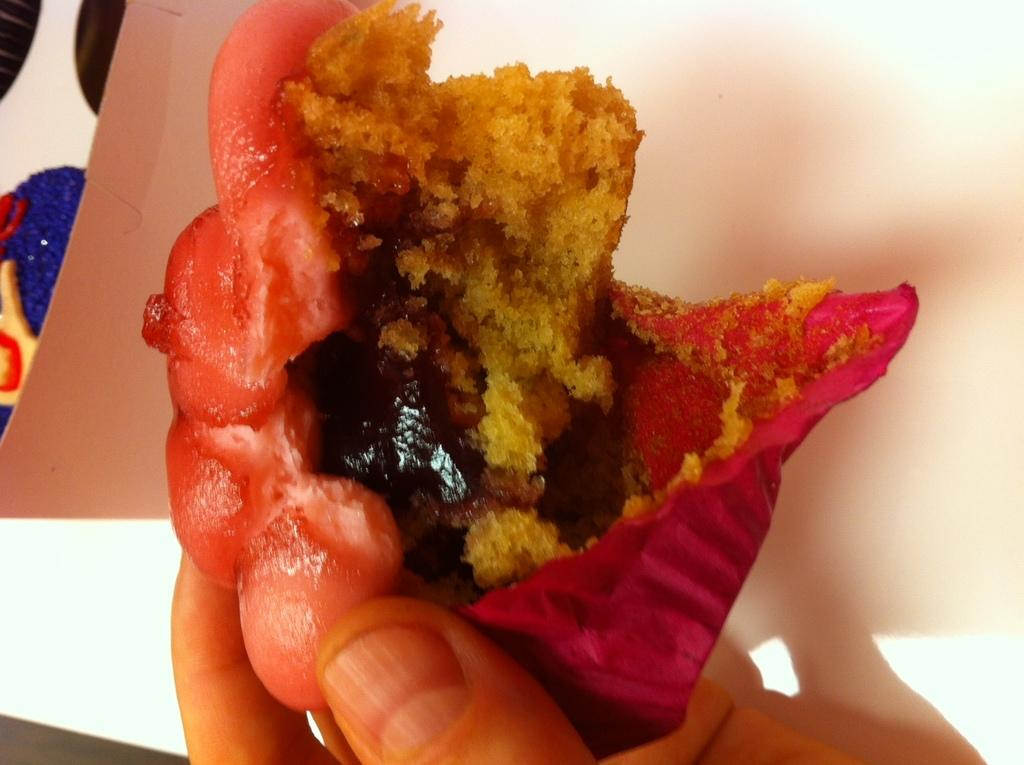What is being held by the person's hand in the foreground of the image? There is a person's hand holding a cupcake piece in the foreground of the image. What can be seen in the background of the image? There is a cardboard box in the background of the image. How many boys are present in the image? There is no information about boys in the image, as it only features a person's hand holding a cupcake piece and a cardboard box in the background. 